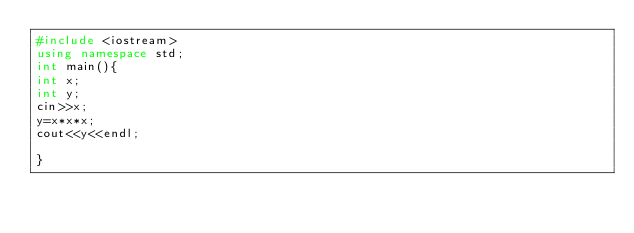<code> <loc_0><loc_0><loc_500><loc_500><_C++_>#include <iostream>
using namespace std;
int main(){
int x;
int y;
cin>>x;
y=x*x*x;
cout<<y<<endl;

}
</code> 